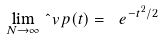Convert formula to latex. <formula><loc_0><loc_0><loc_500><loc_500>\lim _ { N \to \infty } \hat { \ } v p ( t ) = \ e ^ { - t ^ { 2 } / 2 }</formula> 